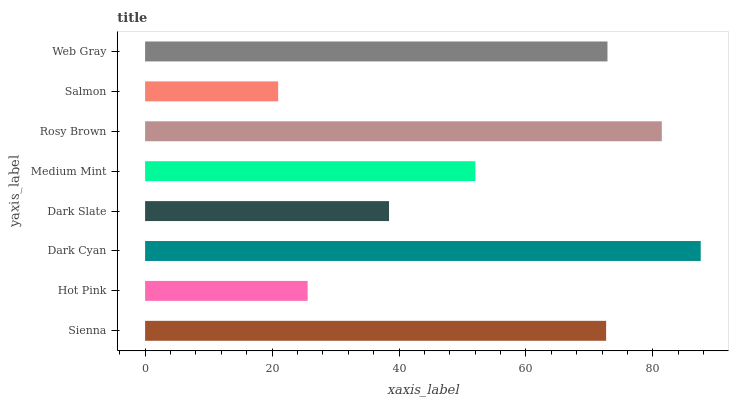Is Salmon the minimum?
Answer yes or no. Yes. Is Dark Cyan the maximum?
Answer yes or no. Yes. Is Hot Pink the minimum?
Answer yes or no. No. Is Hot Pink the maximum?
Answer yes or no. No. Is Sienna greater than Hot Pink?
Answer yes or no. Yes. Is Hot Pink less than Sienna?
Answer yes or no. Yes. Is Hot Pink greater than Sienna?
Answer yes or no. No. Is Sienna less than Hot Pink?
Answer yes or no. No. Is Sienna the high median?
Answer yes or no. Yes. Is Medium Mint the low median?
Answer yes or no. Yes. Is Salmon the high median?
Answer yes or no. No. Is Sienna the low median?
Answer yes or no. No. 